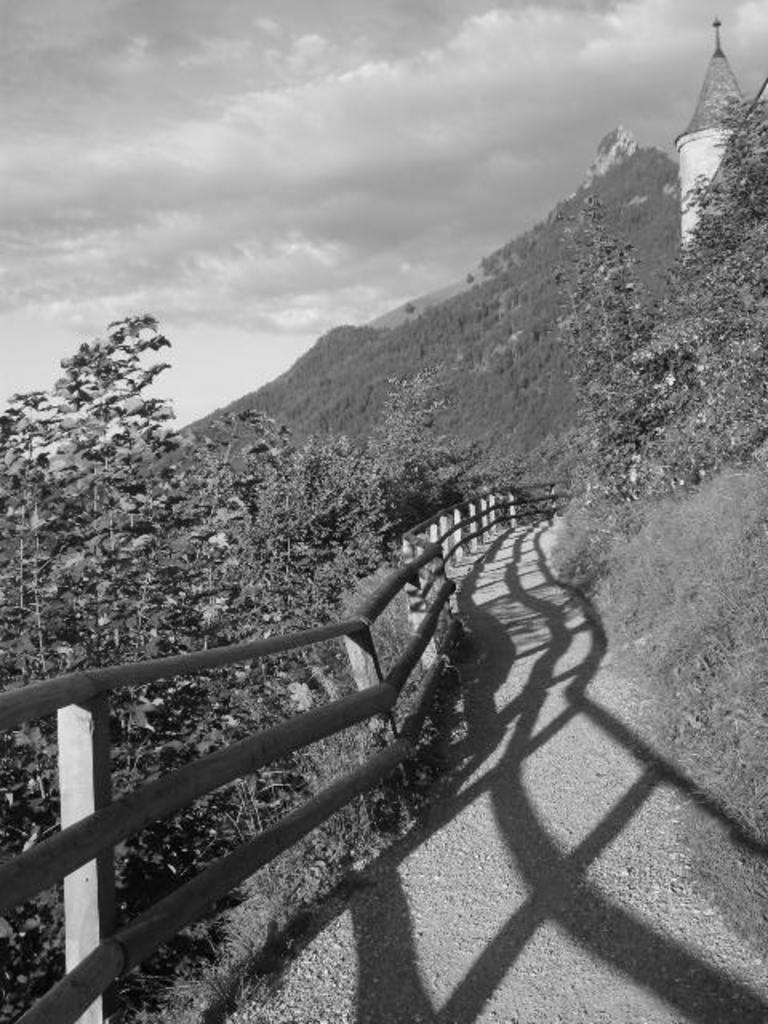What is located at the front of the image? There is a fence in the front of the image. What can be seen in the background of the image? There are trees in the background of the image. What is on the right side of the image? There is a tower on the right side of the image. How would you describe the sky in the image? The sky is cloudy. What theory is being discussed in the image? There is no discussion or indication of a theory in the image. Can you see a car in the image? There is no car present in the image. 